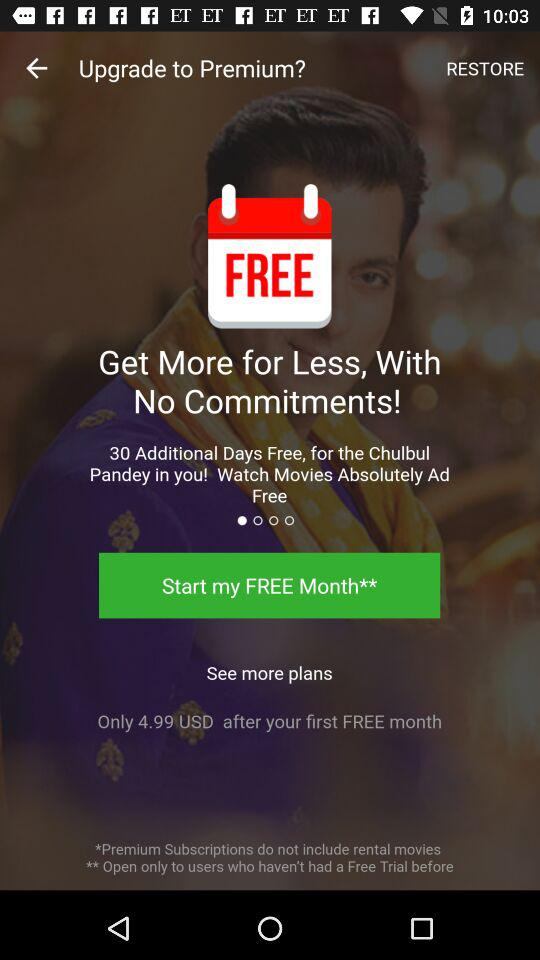How many additional free days will the user get for "Chulbul Pandey in you!"? The user will get 30 additional free days. 